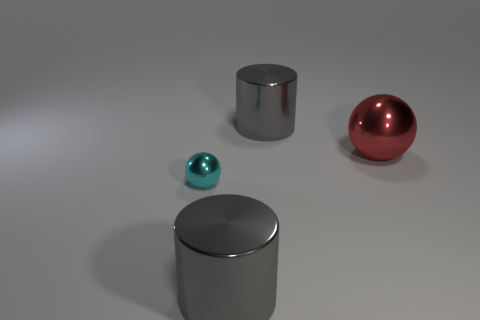Add 4 cyan metallic things. How many objects exist? 8 Add 4 small spheres. How many small spheres are left? 5 Add 2 tiny purple cubes. How many tiny purple cubes exist? 2 Subtract 1 red balls. How many objects are left? 3 Subtract all tiny green rubber things. Subtract all balls. How many objects are left? 2 